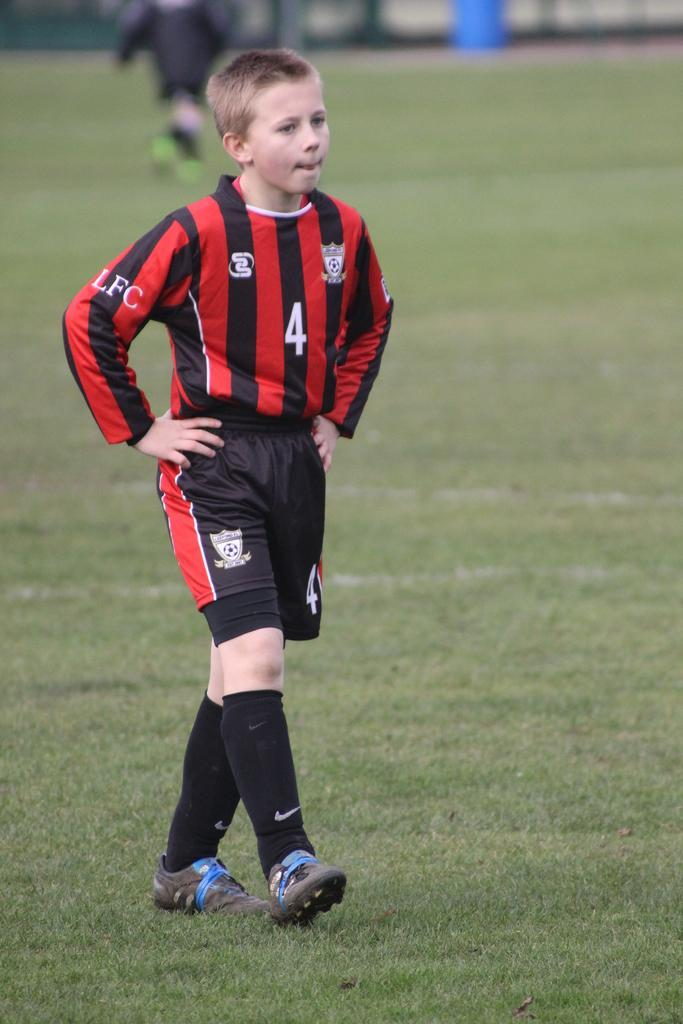What is the main action of the person in the middle of the image? There is a person walking in the middle of the image. Can you describe the position of the second person in the image? There is a person standing behind the walking person. What type of terrain is visible at the bottom of the image? Grass is visible at the bottom of the image. How would you describe the background of the image? The background of the image is blurred. What type of glue is being used by the person in the image? There is no glue present in the image; it features two people walking and standing. What body part is the person using to walk in the image? The person is using their legs to walk in the image. 